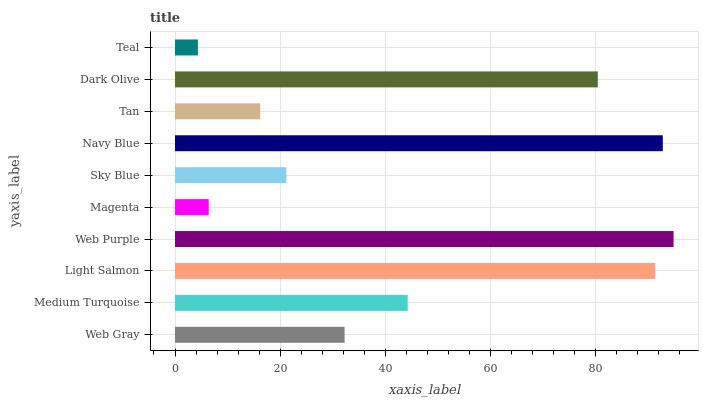Is Teal the minimum?
Answer yes or no. Yes. Is Web Purple the maximum?
Answer yes or no. Yes. Is Medium Turquoise the minimum?
Answer yes or no. No. Is Medium Turquoise the maximum?
Answer yes or no. No. Is Medium Turquoise greater than Web Gray?
Answer yes or no. Yes. Is Web Gray less than Medium Turquoise?
Answer yes or no. Yes. Is Web Gray greater than Medium Turquoise?
Answer yes or no. No. Is Medium Turquoise less than Web Gray?
Answer yes or no. No. Is Medium Turquoise the high median?
Answer yes or no. Yes. Is Web Gray the low median?
Answer yes or no. Yes. Is Dark Olive the high median?
Answer yes or no. No. Is Light Salmon the low median?
Answer yes or no. No. 